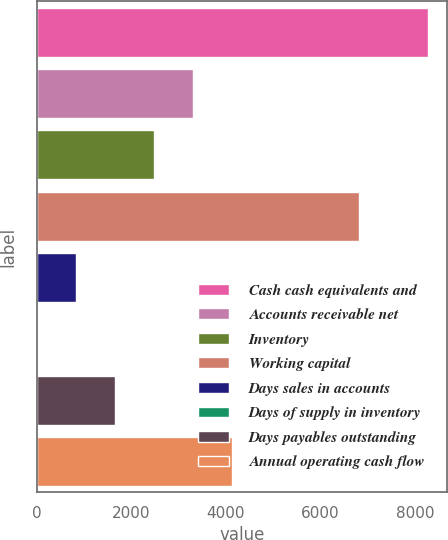Convert chart to OTSL. <chart><loc_0><loc_0><loc_500><loc_500><bar_chart><fcel>Cash cash equivalents and<fcel>Accounts receivable net<fcel>Inventory<fcel>Working capital<fcel>Days sales in accounts<fcel>Days of supply in inventory<fcel>Days payables outstanding<fcel>Annual operating cash flow<nl><fcel>8261<fcel>3308<fcel>2482.5<fcel>6813<fcel>831.5<fcel>6<fcel>1657<fcel>4133.5<nl></chart> 